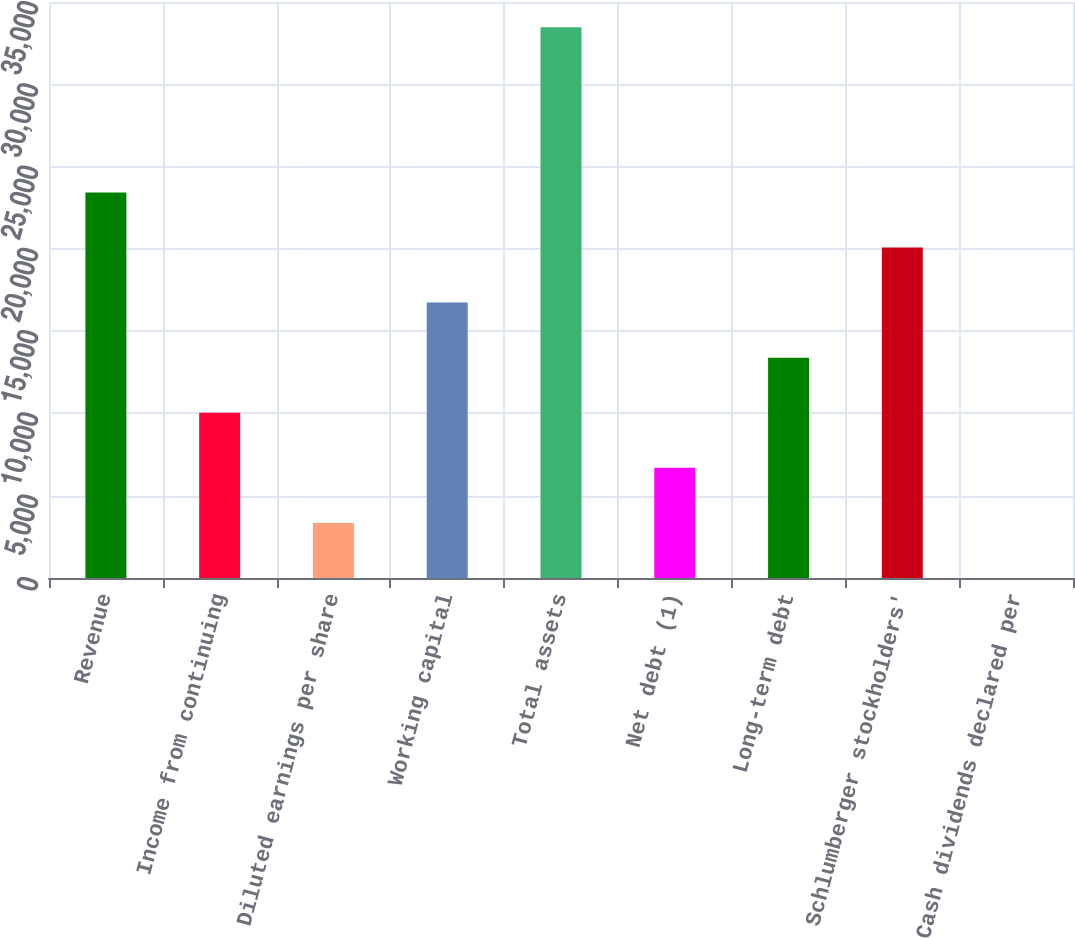<chart> <loc_0><loc_0><loc_500><loc_500><bar_chart><fcel>Revenue<fcel>Income from continuing<fcel>Diluted earnings per share<fcel>Working capital<fcel>Total assets<fcel>Net debt (1)<fcel>Long-term debt<fcel>Schlumberger stockholders'<fcel>Cash dividends declared per<nl><fcel>23425.8<fcel>10040.1<fcel>3347.26<fcel>16732.9<fcel>33465<fcel>6693.68<fcel>13386.5<fcel>20079.4<fcel>0.84<nl></chart> 